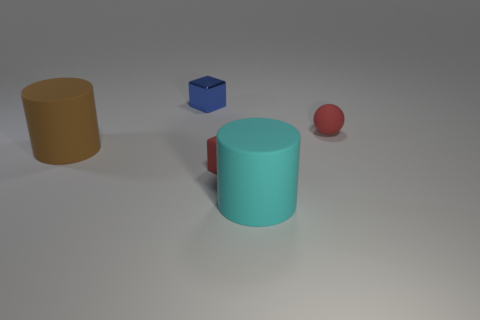There is a matte object that is on the left side of the object behind the tiny ball; what is its shape?
Your response must be concise. Cylinder. Is the shape of the large object to the left of the cyan thing the same as  the cyan thing?
Your answer should be very brief. Yes. What is the color of the tiny rubber object that is in front of the big brown cylinder?
Provide a short and direct response. Red. How many cubes are either cyan matte objects or big brown objects?
Give a very brief answer. 0. How big is the block that is behind the red thing right of the cyan object?
Provide a short and direct response. Small. Is the color of the metallic object the same as the tiny rubber thing on the left side of the ball?
Offer a very short reply. No. What number of small metallic things are on the left side of the small red ball?
Give a very brief answer. 1. Is the number of large brown matte cylinders less than the number of tiny brown metal cylinders?
Offer a very short reply. No. There is a thing that is both to the right of the tiny blue cube and behind the large brown cylinder; what size is it?
Provide a succinct answer. Small. There is a cube that is in front of the tiny blue metallic object; is it the same color as the tiny matte ball?
Your answer should be very brief. Yes. 